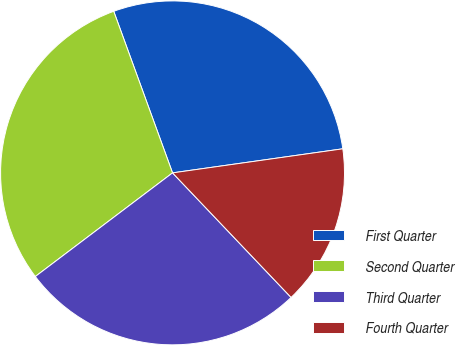Convert chart to OTSL. <chart><loc_0><loc_0><loc_500><loc_500><pie_chart><fcel>First Quarter<fcel>Second Quarter<fcel>Third Quarter<fcel>Fourth Quarter<nl><fcel>28.32%<fcel>29.74%<fcel>26.81%<fcel>15.13%<nl></chart> 